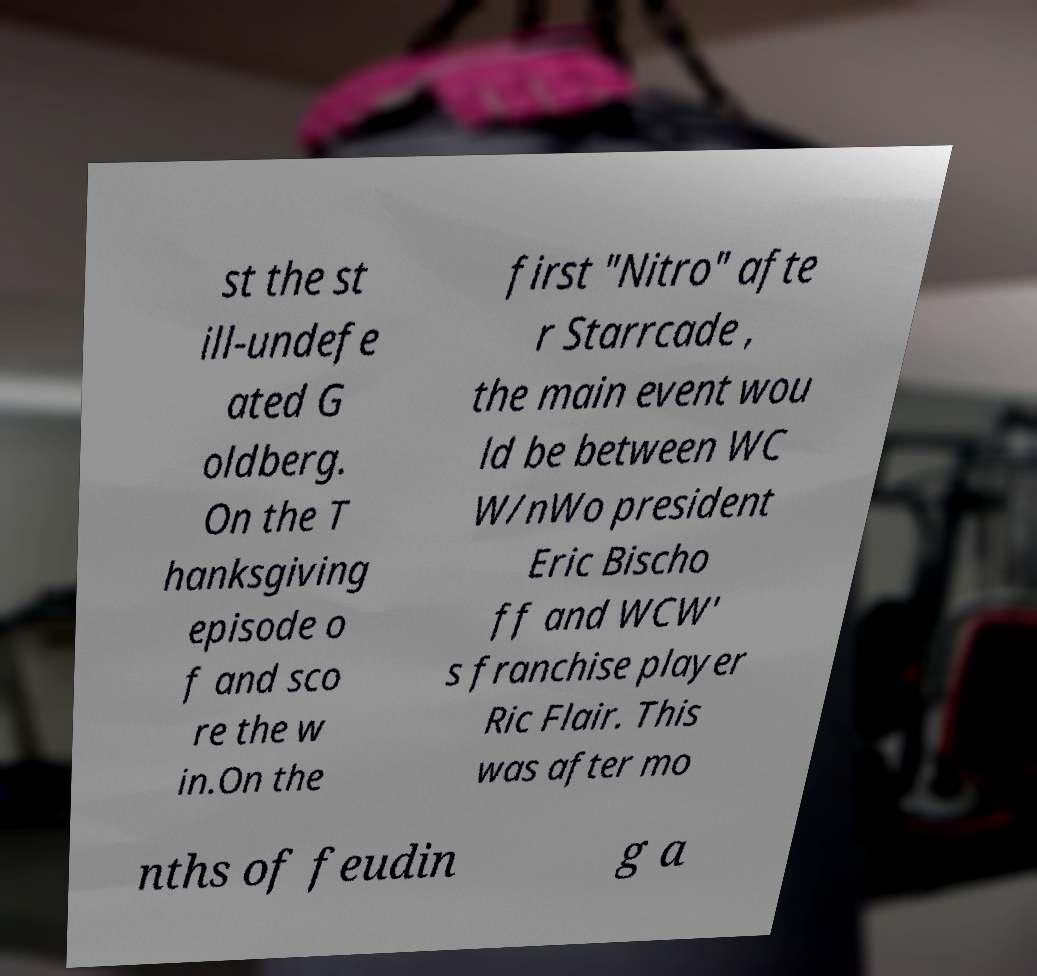Could you extract and type out the text from this image? st the st ill-undefe ated G oldberg. On the T hanksgiving episode o f and sco re the w in.On the first "Nitro" afte r Starrcade , the main event wou ld be between WC W/nWo president Eric Bischo ff and WCW' s franchise player Ric Flair. This was after mo nths of feudin g a 